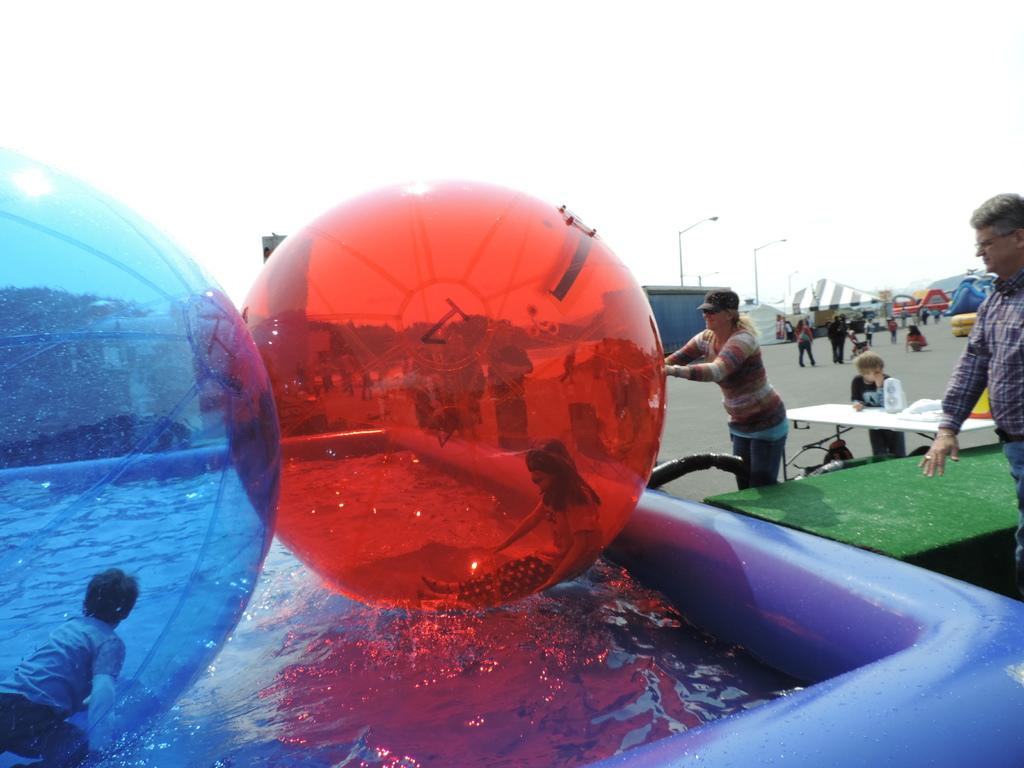What are the persons in the image doing? The persons in water balloons are floating on the water. What are the persons standing on? The persons standing on the floor. What type of structures can be seen in the image? Street poles and tents are visible in the image. What is the condition of the sky in the image? The sky is visible in the image. What other objects are present in the image? Street lights are present in the image. Can you see any jellyfish swimming in the water with the persons in water balloons? No, there are no jellyfish visible in the image; only persons in water balloons and persons standing on the floor can be seen. Is there a man playing baseball in the image? No, there is no man playing baseball in the image; the activities depicted are related to water balloons and standing on the floor. 